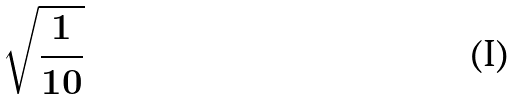Convert formula to latex. <formula><loc_0><loc_0><loc_500><loc_500>\sqrt { \frac { 1 } { 1 0 } }</formula> 